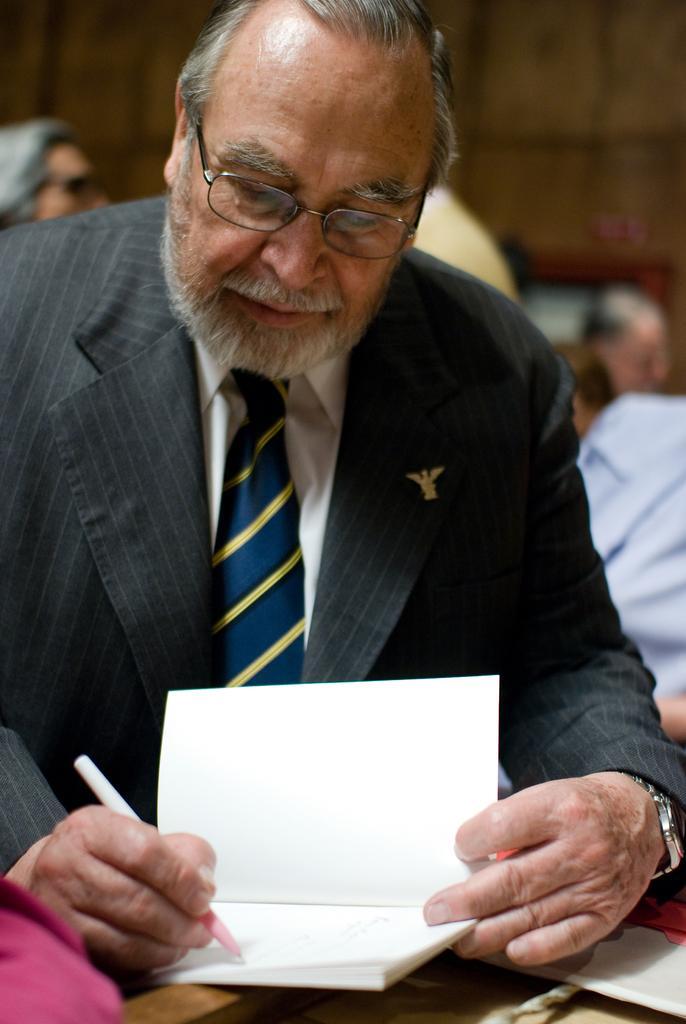In one or two sentences, can you explain what this image depicts? In this picture we can see a person, he is wearing a tie, spectacles and holding a pen, here we can see a book and some objects and in the background we can see a group of people, wall and an object. 